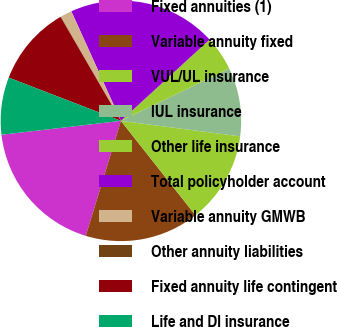<chart> <loc_0><loc_0><loc_500><loc_500><pie_chart><fcel>Fixed annuities (1)<fcel>Variable annuity fixed<fcel>VUL/UL insurance<fcel>IUL insurance<fcel>Other life insurance<fcel>Total policyholder account<fcel>Variable annuity GMWB<fcel>Other annuity liabilities<fcel>Fixed annuity life contingent<fcel>Life and DI insurance<nl><fcel>18.43%<fcel>15.36%<fcel>12.3%<fcel>9.23%<fcel>4.64%<fcel>19.96%<fcel>1.57%<fcel>0.04%<fcel>10.77%<fcel>7.7%<nl></chart> 